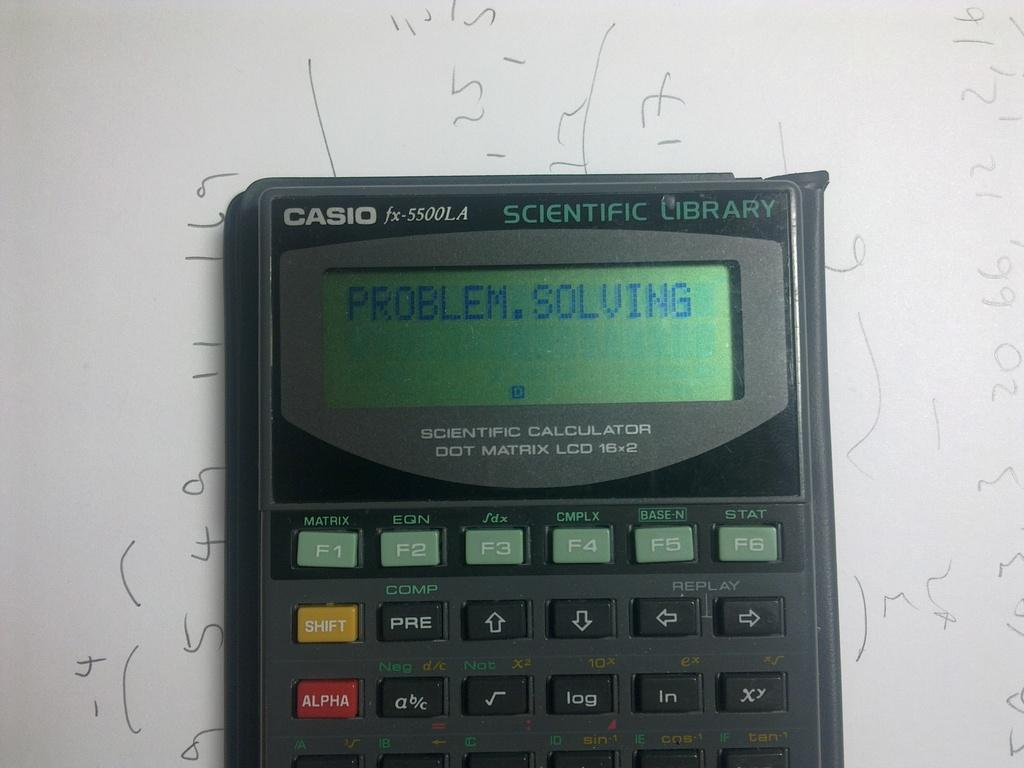<image>
Create a compact narrative representing the image presented. A Casio Scientific Calculator turned on and set for problem solving. 